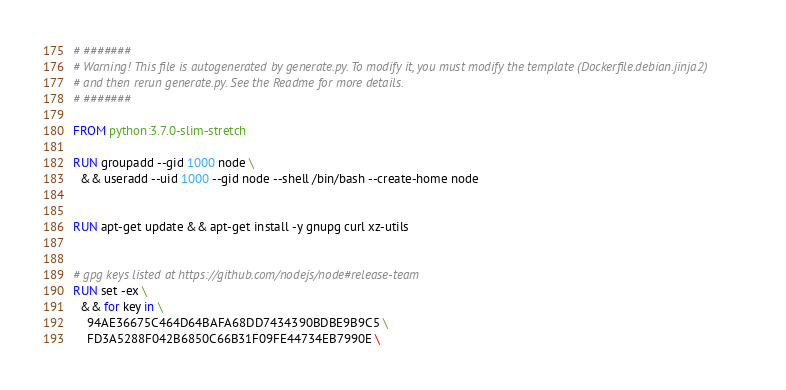<code> <loc_0><loc_0><loc_500><loc_500><_Dockerfile_># #######
# Warning! This file is autogenerated by generate.py. To modify it, you must modify the template (Dockerfile.debian.jinja2)
# and then rerun generate.py. See the Readme for more details.
# #######

FROM python:3.7.0-slim-stretch

RUN groupadd --gid 1000 node \
  && useradd --uid 1000 --gid node --shell /bin/bash --create-home node


RUN apt-get update && apt-get install -y gnupg curl xz-utils


# gpg keys listed at https://github.com/nodejs/node#release-team
RUN set -ex \
  && for key in \
    94AE36675C464D64BAFA68DD7434390BDBE9B9C5 \
    FD3A5288F042B6850C66B31F09FE44734EB7990E \</code> 